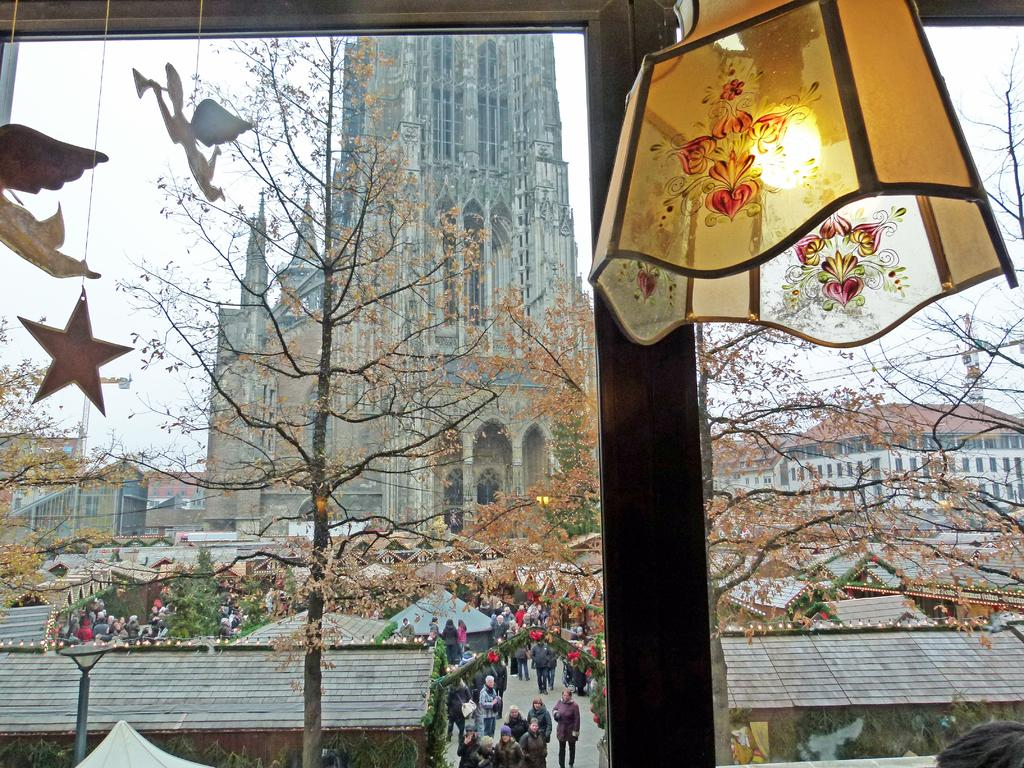What is the source of light in the image? There is a light in the image. What type of natural elements can be seen in the image? There are trees in the image. What can be seen in the distance in the image? There are buildings in the background of the image. Are there any people visible in the image? Yes, there is a group of people in the background of the image. What type of vest is being worn by the tree in the image? There are no vests present in the image, as trees do not wear clothing. How many wheels can be seen on the light in the image? There are no wheels present in the image, as the light is not a vehicle or object with wheels. 